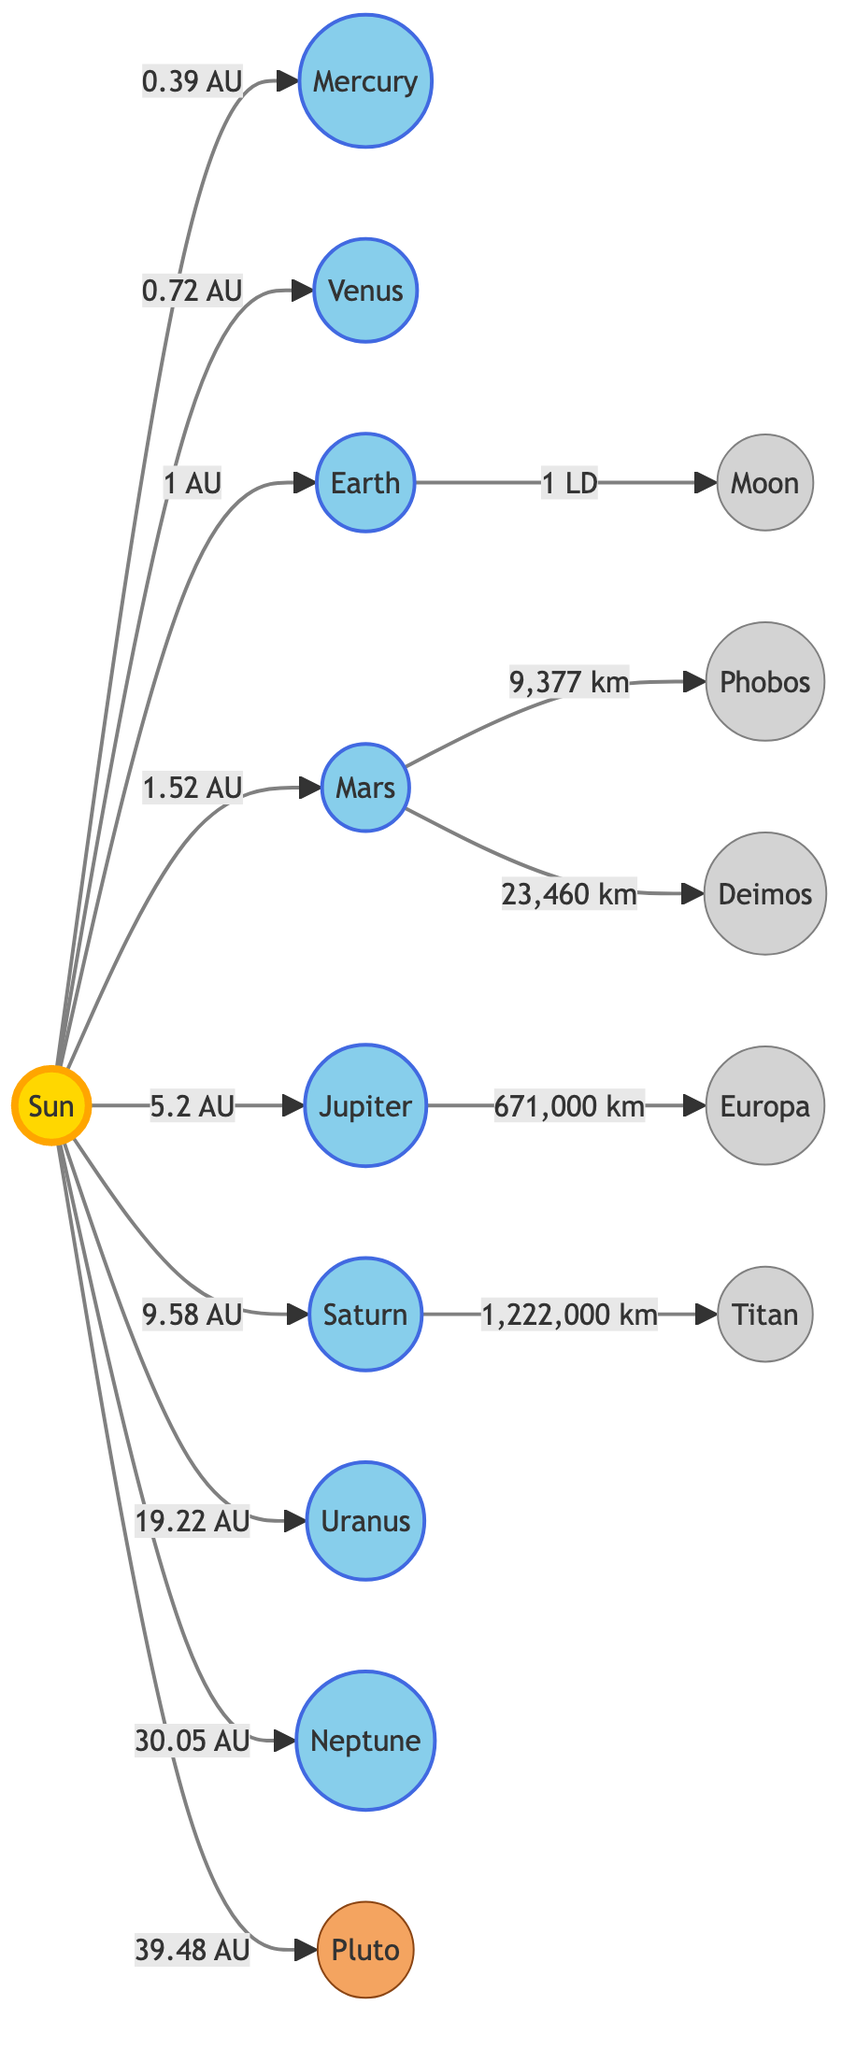What is the distance from the Sun to Earth? According to the diagram, the distance from the Sun to Earth is labeled as 1 AU.
Answer: 1 AU Which planet is closest to the Sun? The diagram shows that Mercury is connected directly to the Sun with a label of 0.39 AU, indicating it is the closest planet.
Answer: Mercury How many major moons are shown in the diagram? By counting the moons associated with the planets in the diagram—Moon, Phobos, Deimos, Europa, and Titan—we find a total of five major moons.
Answer: 5 What is the orbit distance of Neptune from the Sun? The diagram states the distance from the Sun to Neptune is marked as 30.05 AU.
Answer: 30.05 AU Which planet has the largest orbit around the Sun in this diagram? Looking at the distances marked in the diagram, Pluto is the last planet listed with a distance of 39.48 AU, indicating it has the largest orbit.
Answer: Pluto How far is Mars from the Sun? The connection between the Sun and Mars in the diagram shows a distance of 1.52 AU.
Answer: 1.52 AU Which planet has a moon named Titan? The diagram connects Saturn to Titan, indicating that Titan is the moon of Saturn.
Answer: Saturn How many dwarf planets are indicated in the diagram? The diagram specifies that there is one dwarf planet shown, which is Pluto.
Answer: 1 What is the relationship between Earth and its Moon according to the diagram? The diagram illustrates that Earth has a direct connection to the Moon, indicating that the Moon orbits around Earth at a distance of 1 LD.
Answer: 1 LD 